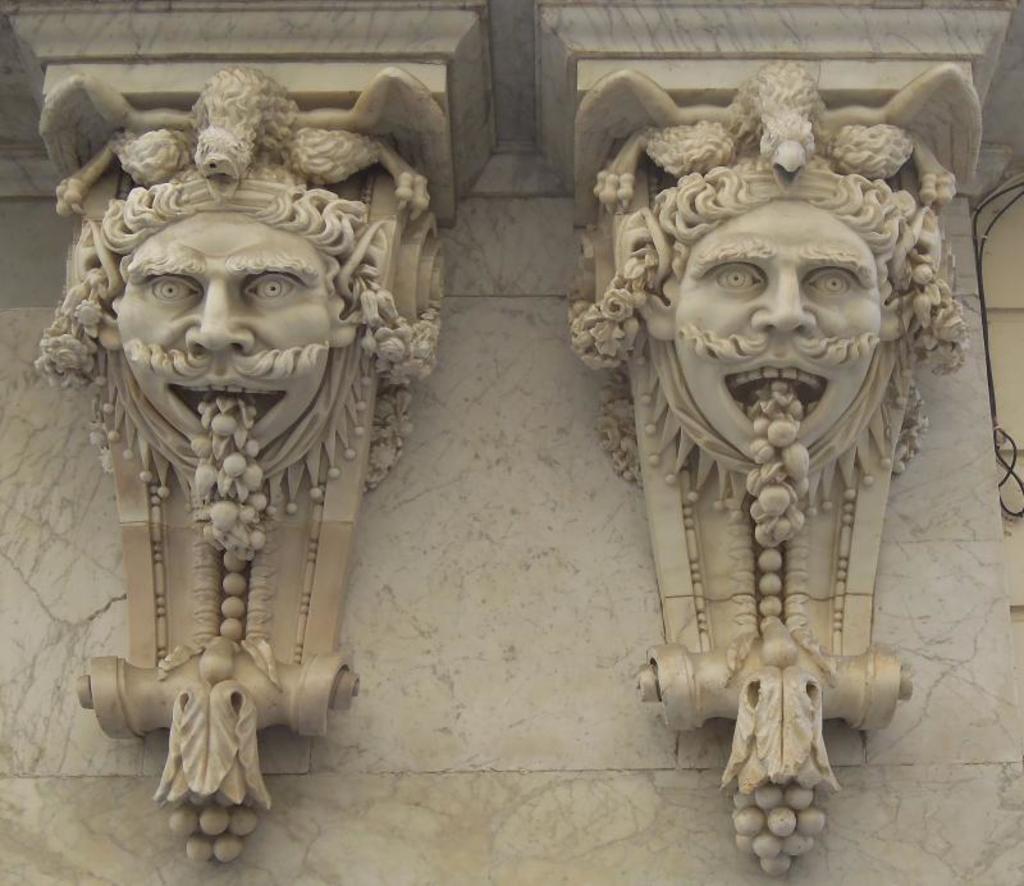Please provide a concise description of this image. In this picture we can see the sculptures on the wall. On the right side of the image we can see a cable. 